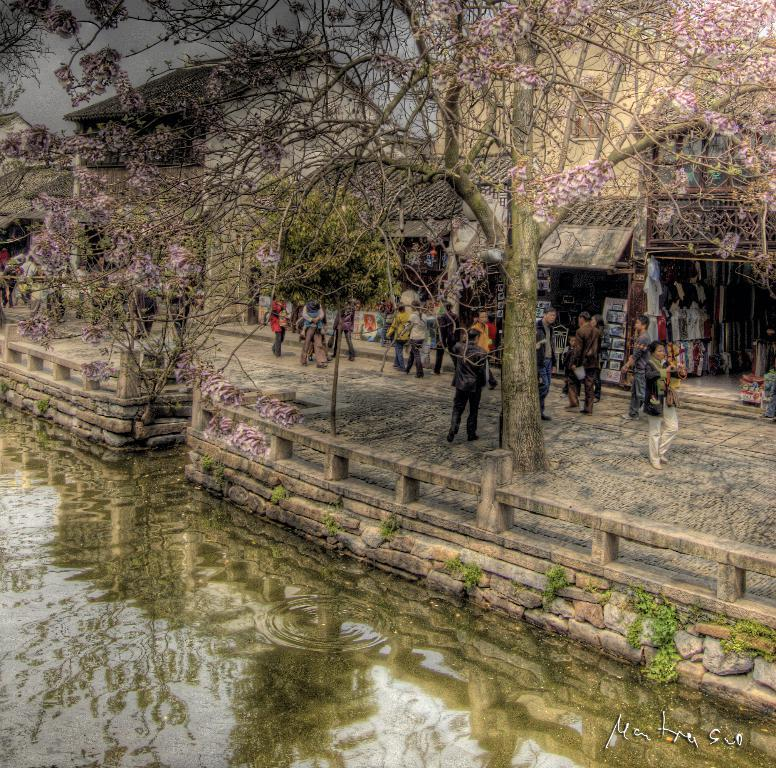What are the people in the image doing? The persons in the image are walking on the pavement. Where is the pavement located in relation to the buildings? The pavement is in front of the shops of the buildings. What type of vegetation is present in front of the buildings? There are trees in front of the buildings. What natural feature can be seen in the image? There is a lake visible in the image. What type of whip can be seen in the hands of the persons walking on the pavement? There is no whip present in the image; the persons are simply walking on the pavement. Are there any bears visible in the image? No, there are no bears present in the image. 